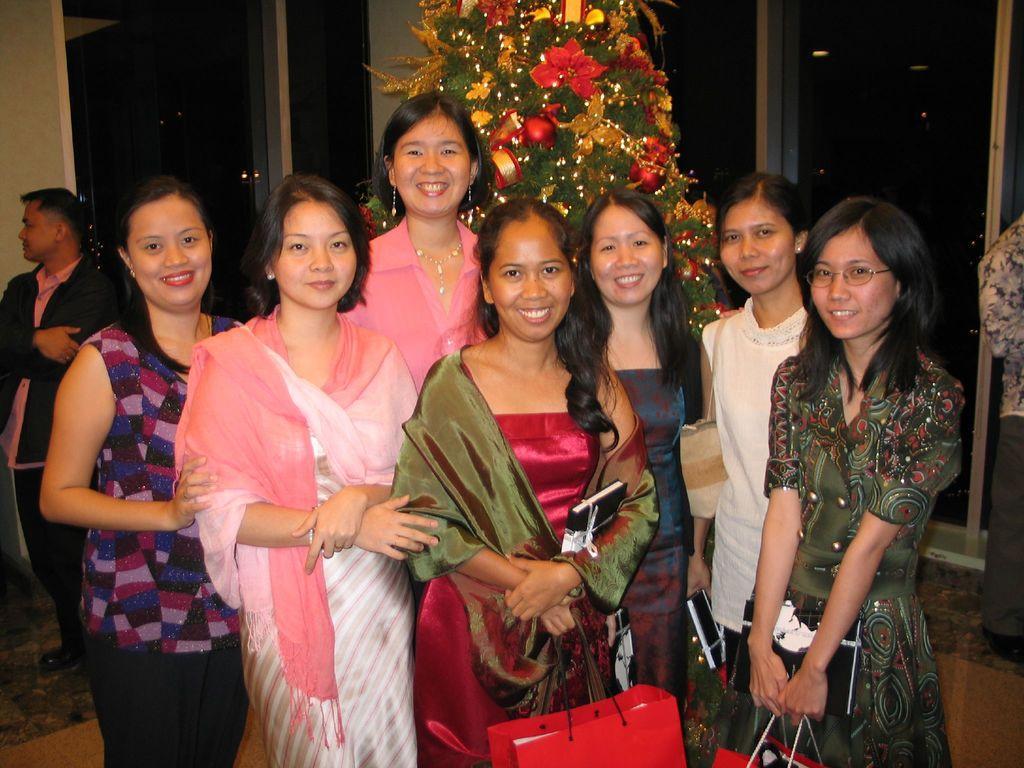Could you give a brief overview of what you see in this image? This picture describes about group of people, few are smiling and few people holding bags, behind them we can see a Christmas tree and we can find dark background. 